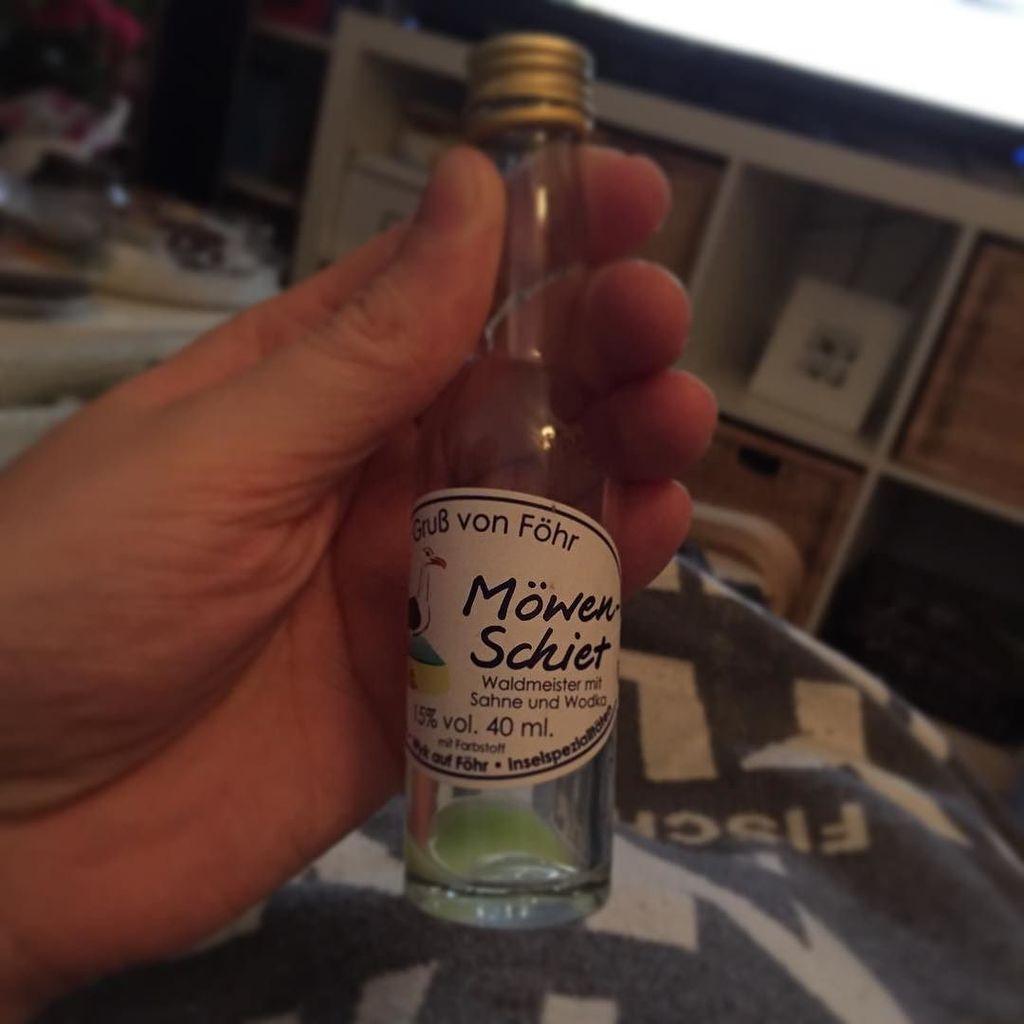In one or two sentences, can you explain what this image depicts? In this picture we can see a bottle hold by some persons hand and in background we can see racks and it is blurry. 